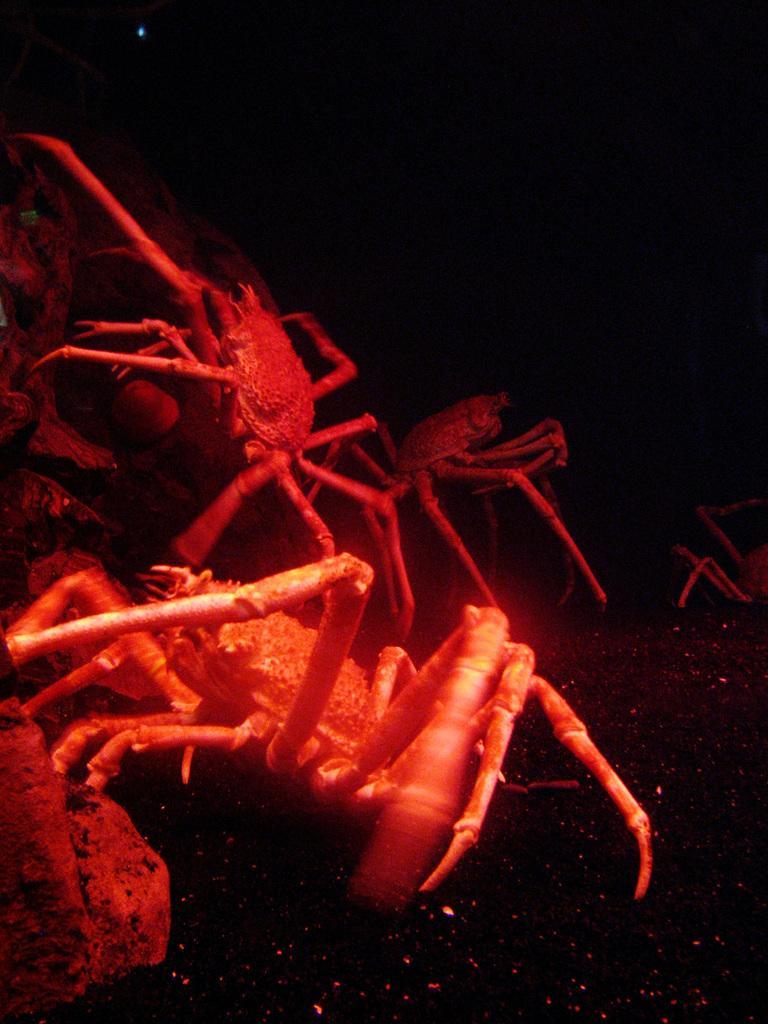Describe this image in one or two sentences. In this image I can see few red colour crabs. I can also see this image is little bit in dark. 